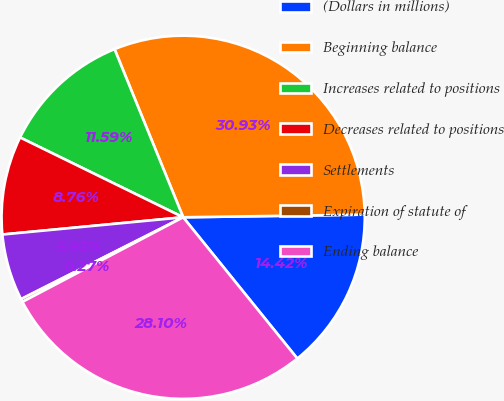Convert chart. <chart><loc_0><loc_0><loc_500><loc_500><pie_chart><fcel>(Dollars in millions)<fcel>Beginning balance<fcel>Increases related to positions<fcel>Decreases related to positions<fcel>Settlements<fcel>Expiration of statute of<fcel>Ending balance<nl><fcel>14.42%<fcel>30.94%<fcel>11.59%<fcel>8.76%<fcel>5.93%<fcel>0.27%<fcel>28.11%<nl></chart> 